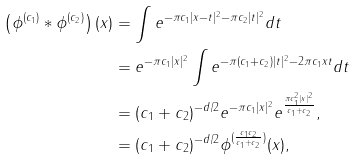<formula> <loc_0><loc_0><loc_500><loc_500>\left ( \phi ^ { ( c _ { 1 } ) } \ast \phi ^ { ( c _ { 2 } ) } \right ) ( x ) & = \int e ^ { - \pi c _ { 1 } | x - t | ^ { 2 } - \pi c _ { 2 } | t | ^ { 2 } } d t \\ & = e ^ { - \pi c _ { 1 } | x | ^ { 2 } } \int e ^ { - \pi ( c _ { 1 } + c _ { 2 } ) | t | ^ { 2 } - 2 \pi c _ { 1 } x t } d t \\ & = ( c _ { 1 } + c _ { 2 } ) ^ { - d / 2 } e ^ { - \pi c _ { 1 } | x | ^ { 2 } } e ^ { \frac { \pi c _ { 1 } ^ { 2 } | x | ^ { 2 } } { c _ { 1 } + c _ { 2 } } } , \\ & = ( c _ { 1 } + c _ { 2 } ) ^ { - d / 2 } \phi ^ { ( \frac { c _ { 1 } c _ { 2 } } { c _ { 1 } + c _ { 2 } } ) } ( x ) ,</formula> 